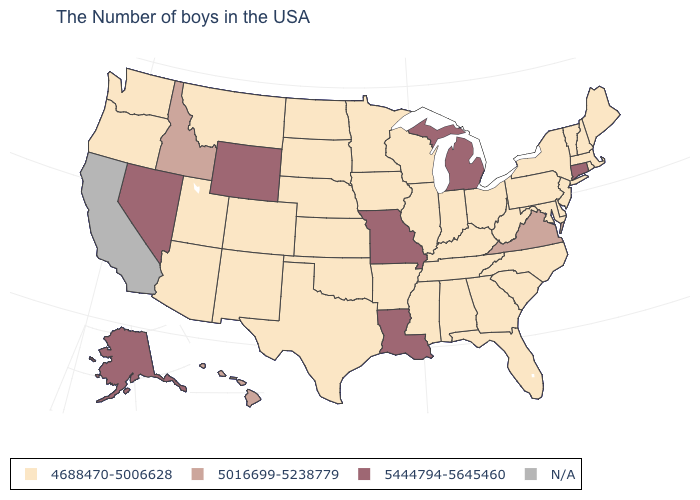What is the value of Vermont?
Give a very brief answer. 4688470-5006628. How many symbols are there in the legend?
Write a very short answer. 4. Is the legend a continuous bar?
Write a very short answer. No. Which states have the lowest value in the West?
Be succinct. Colorado, New Mexico, Utah, Montana, Arizona, Washington, Oregon. Name the states that have a value in the range N/A?
Answer briefly. California. Does the first symbol in the legend represent the smallest category?
Give a very brief answer. Yes. Is the legend a continuous bar?
Be succinct. No. Name the states that have a value in the range 5016699-5238779?
Be succinct. Virginia, Idaho, Hawaii. Among the states that border Vermont , which have the lowest value?
Write a very short answer. Massachusetts, New Hampshire, New York. Does the map have missing data?
Short answer required. Yes. Among the states that border Utah , does Arizona have the highest value?
Give a very brief answer. No. Which states have the highest value in the USA?
Answer briefly. Connecticut, Michigan, Louisiana, Missouri, Wyoming, Nevada, Alaska. What is the lowest value in the USA?
Concise answer only. 4688470-5006628. What is the value of California?
Answer briefly. N/A. 